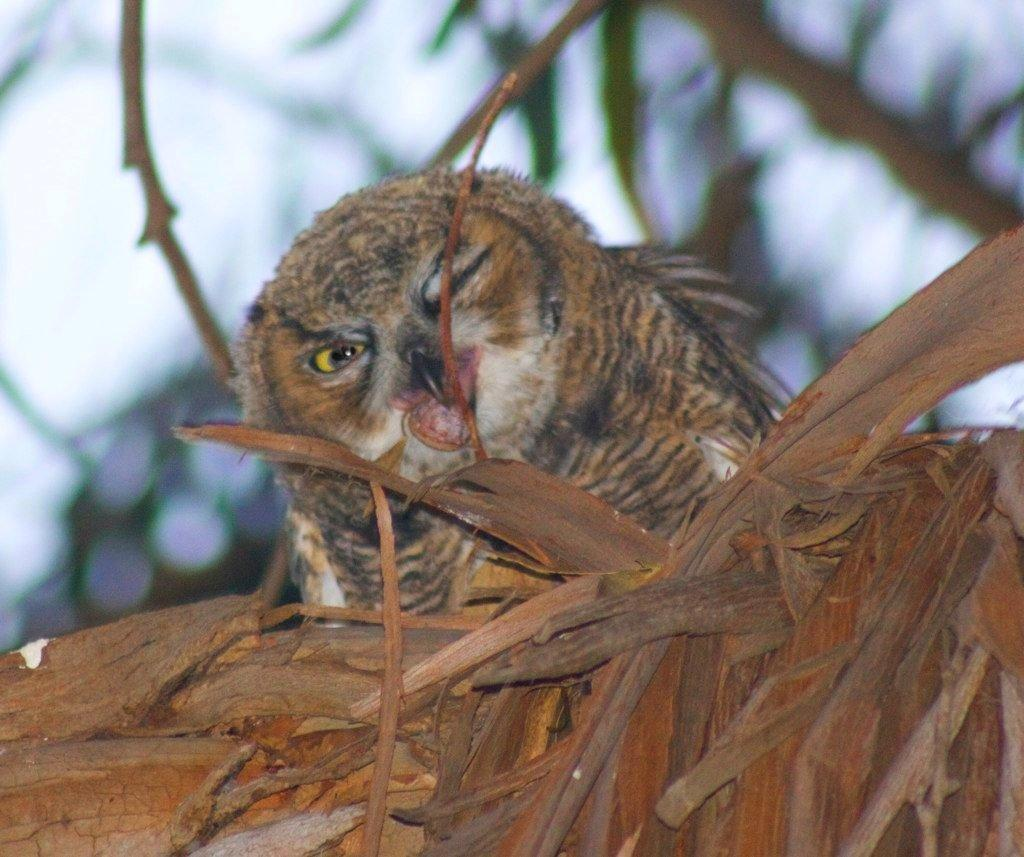What animal is in the image? There is an owl in the image. Where is the owl sitting? The owl is sitting on a tree trunk. Can you describe the background of the image? The background of the image is blurred. What type of mist can be seen surrounding the island in the image? There is no island or mist present in the image; it features an owl sitting on a tree trunk with a blurred background. 